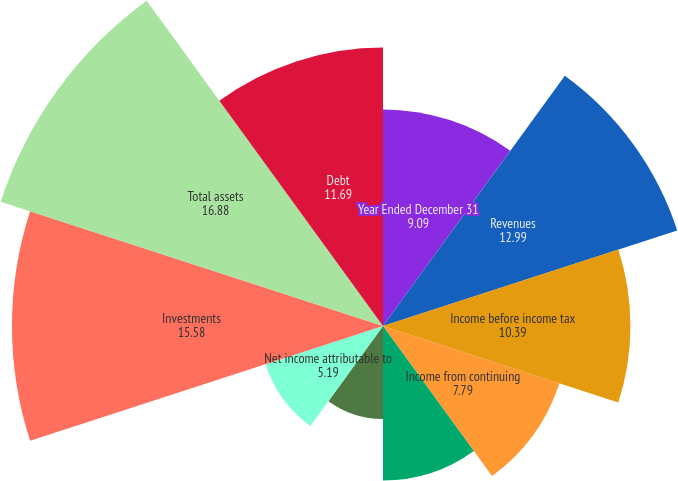Convert chart to OTSL. <chart><loc_0><loc_0><loc_500><loc_500><pie_chart><fcel>Year Ended December 31<fcel>Revenues<fcel>Income before income tax<fcel>Income from continuing<fcel>Net income<fcel>Amounts attributable to<fcel>Net income attributable to<fcel>Investments<fcel>Total assets<fcel>Debt<nl><fcel>9.09%<fcel>12.99%<fcel>10.39%<fcel>7.79%<fcel>6.49%<fcel>3.9%<fcel>5.19%<fcel>15.58%<fcel>16.88%<fcel>11.69%<nl></chart> 